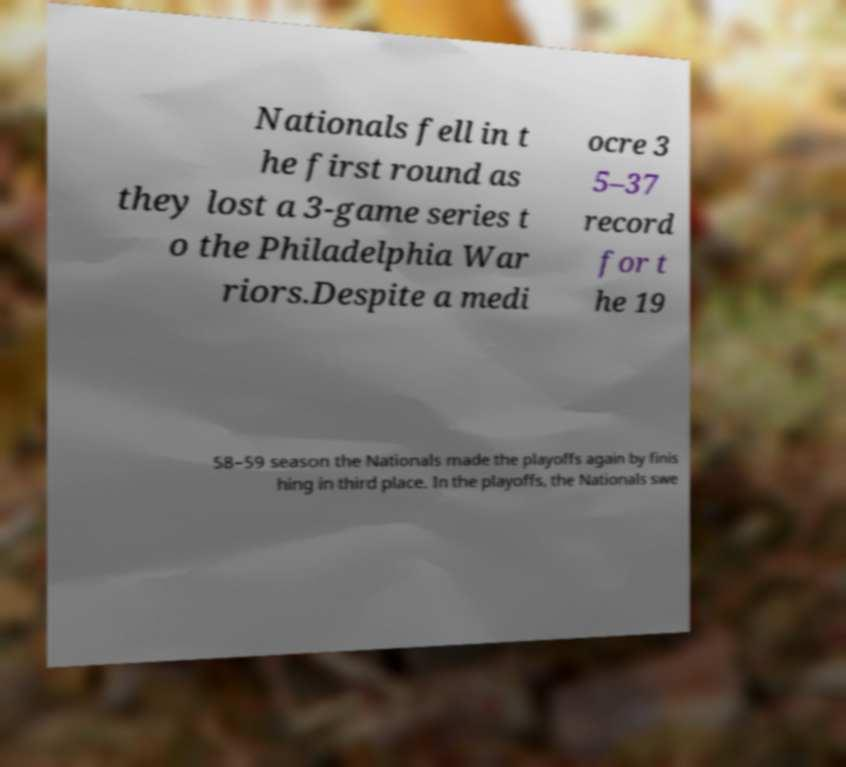I need the written content from this picture converted into text. Can you do that? Nationals fell in t he first round as they lost a 3-game series t o the Philadelphia War riors.Despite a medi ocre 3 5–37 record for t he 19 58–59 season the Nationals made the playoffs again by finis hing in third place. In the playoffs, the Nationals swe 